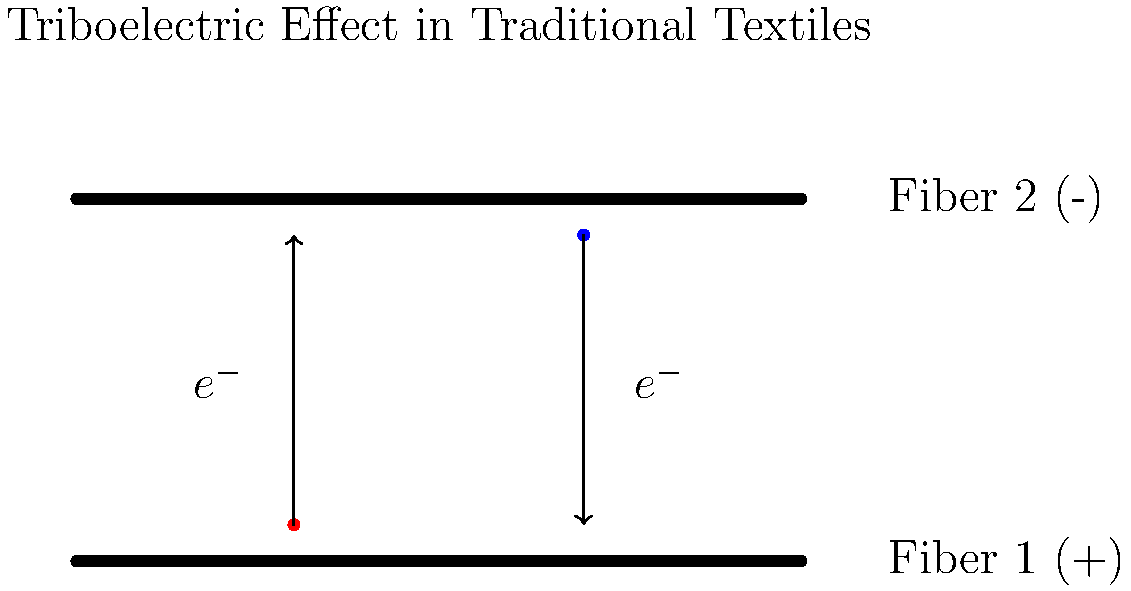In traditional Latin American textile production, the triboelectric effect often occurs between different fibers. Consider two types of fibers commonly used: wool and cotton. Which fiber is more likely to become positively charged when rubbed against the other, and why is this relevant to your anthropological research on traditional textile practices? To answer this question, let's break it down step-by-step:

1. The triboelectric effect is the electrical charge that occurs when certain materials are brought into contact and then separated.

2. In the triboelectric series, materials are ranked according to their tendency to gain or lose electrons when brought into contact with other materials.

3. Wool is higher in the triboelectric series than cotton. This means:
   - Wool tends to give up electrons more easily.
   - Cotton tends to accept electrons more readily.

4. When wool and cotton fibers are rubbed together:
   - Wool loses electrons and becomes positively charged $(+)$.
   - Cotton gains electrons and becomes negatively charged $(-)$.

5. The relevance to anthropological research on traditional textile practices:
   - Understanding this effect helps explain traditional knowledge about fiber combinations.
   - It can provide insights into why certain fibers were preferred for specific garments or purposes.
   - The effect influences the behavior of fibers during spinning and weaving, potentially affecting traditional techniques.
   - Static buildup due to this effect might have influenced storage and handling practices of textiles.
   - The phenomenon could have cultural significance, possibly relating to beliefs about energy or properties of different materials.

6. This scientific understanding can bridge gaps between modern materials science and traditional craftsmanship, offering a deeper appreciation of indigenous knowledge systems.
Answer: Wool becomes positively charged; relevant for understanding traditional fiber selection, textile techniques, and cultural practices. 